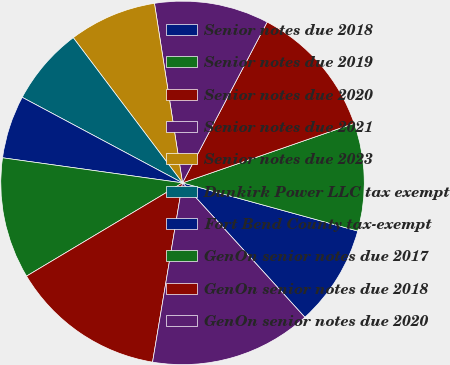<chart> <loc_0><loc_0><loc_500><loc_500><pie_chart><fcel>Senior notes due 2018<fcel>Senior notes due 2019<fcel>Senior notes due 2020<fcel>Senior notes due 2021<fcel>Senior notes due 2023<fcel>Dunkirk Power LLC tax exempt<fcel>Fort Bend County tax-exempt<fcel>GenOn senior notes due 2017<fcel>GenOn senior notes due 2018<fcel>GenOn senior notes due 2020<nl><fcel>8.98%<fcel>9.58%<fcel>11.98%<fcel>10.18%<fcel>7.8%<fcel>6.93%<fcel>5.6%<fcel>10.78%<fcel>13.79%<fcel>14.39%<nl></chart> 